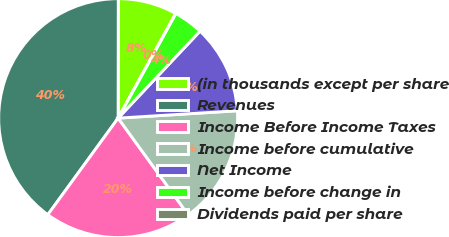Convert chart to OTSL. <chart><loc_0><loc_0><loc_500><loc_500><pie_chart><fcel>(in thousands except per share<fcel>Revenues<fcel>Income Before Income Taxes<fcel>Income before cumulative<fcel>Net Income<fcel>Income before change in<fcel>Dividends paid per share<nl><fcel>8.0%<fcel>40.0%<fcel>20.0%<fcel>16.0%<fcel>12.0%<fcel>4.0%<fcel>0.0%<nl></chart> 